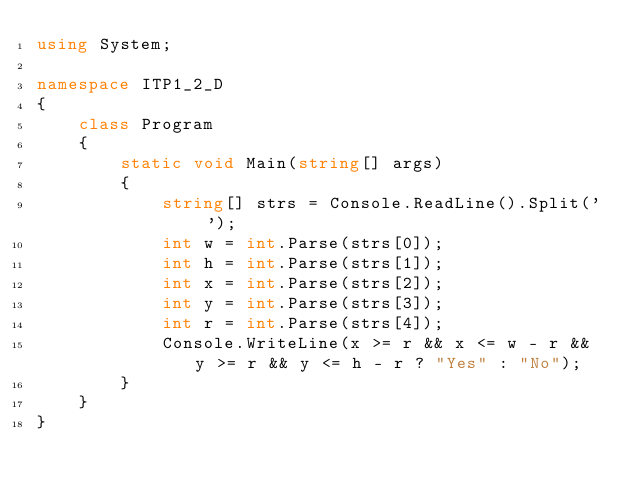Convert code to text. <code><loc_0><loc_0><loc_500><loc_500><_C#_>using System;

namespace ITP1_2_D
{
    class Program
    {
        static void Main(string[] args)
        {
            string[] strs = Console.ReadLine().Split(' ');
            int w = int.Parse(strs[0]);
            int h = int.Parse(strs[1]);
            int x = int.Parse(strs[2]);
            int y = int.Parse(strs[3]);
            int r = int.Parse(strs[4]);
            Console.WriteLine(x >= r && x <= w - r && y >= r && y <= h - r ? "Yes" : "No");
        }
    }
}</code> 